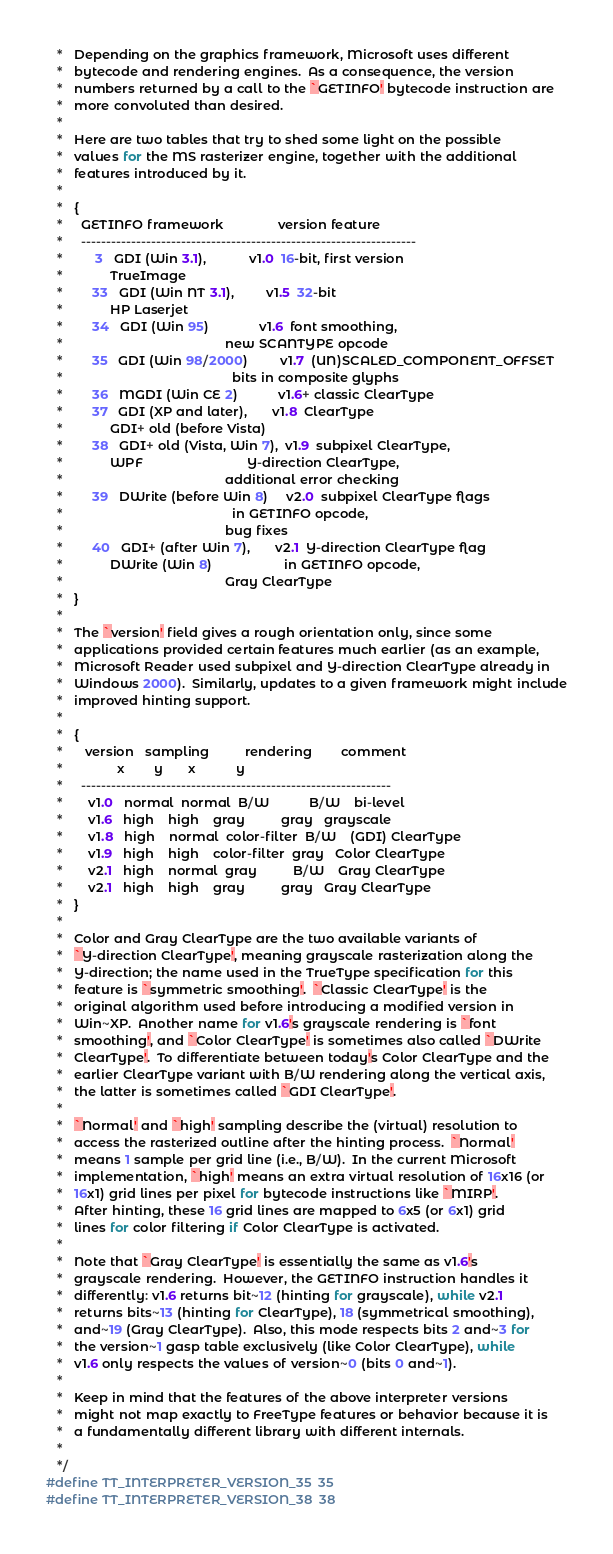<code> <loc_0><loc_0><loc_500><loc_500><_C_>   *   Depending on the graphics framework, Microsoft uses different
   *   bytecode and rendering engines.  As a consequence, the version
   *   numbers returned by a call to the `GETINFO' bytecode instruction are
   *   more convoluted than desired.
   *
   *   Here are two tables that try to shed some light on the possible
   *   values for the MS rasterizer engine, together with the additional
   *   features introduced by it.
   *
   *   {
   *     GETINFO framework               version feature
   *     -------------------------------------------------------------------
   *         3   GDI (Win 3.1),            v1.0  16-bit, first version
   *             TrueImage
   *        33   GDI (Win NT 3.1),         v1.5  32-bit
   *             HP Laserjet
   *        34   GDI (Win 95)              v1.6  font smoothing,
   *                                             new SCANTYPE opcode
   *        35   GDI (Win 98/2000)         v1.7  (UN)SCALED_COMPONENT_OFFSET
   *                                               bits in composite glyphs
   *        36   MGDI (Win CE 2)           v1.6+ classic ClearType
   *        37   GDI (XP and later),       v1.8  ClearType
   *             GDI+ old (before Vista)
   *        38   GDI+ old (Vista, Win 7),  v1.9  subpixel ClearType,
   *             WPF                             Y-direction ClearType,
   *                                             additional error checking
   *        39   DWrite (before Win 8)     v2.0  subpixel ClearType flags
   *                                               in GETINFO opcode,
   *                                             bug fixes
   *        40   GDI+ (after Win 7),       v2.1  Y-direction ClearType flag
   *             DWrite (Win 8)                    in GETINFO opcode,
   *                                             Gray ClearType
   *   }
   *
   *   The `version' field gives a rough orientation only, since some
   *   applications provided certain features much earlier (as an example,
   *   Microsoft Reader used subpixel and Y-direction ClearType already in
   *   Windows 2000).  Similarly, updates to a given framework might include
   *   improved hinting support.
   *
   *   {
   *      version   sampling          rendering        comment
   *               x        y       x           y
   *     --------------------------------------------------------------
   *       v1.0   normal  normal  B/W           B/W    bi-level
   *       v1.6   high    high    gray          gray   grayscale
   *       v1.8   high    normal  color-filter  B/W    (GDI) ClearType
   *       v1.9   high    high    color-filter  gray   Color ClearType
   *       v2.1   high    normal  gray          B/W    Gray ClearType
   *       v2.1   high    high    gray          gray   Gray ClearType
   *   }
   *
   *   Color and Gray ClearType are the two available variants of
   *   `Y-direction ClearType', meaning grayscale rasterization along the
   *   Y-direction; the name used in the TrueType specification for this
   *   feature is `symmetric smoothing'.  `Classic ClearType' is the
   *   original algorithm used before introducing a modified version in
   *   Win~XP.  Another name for v1.6's grayscale rendering is `font
   *   smoothing', and `Color ClearType' is sometimes also called `DWrite
   *   ClearType'.  To differentiate between today's Color ClearType and the
   *   earlier ClearType variant with B/W rendering along the vertical axis,
   *   the latter is sometimes called `GDI ClearType'.
   *
   *   `Normal' and `high' sampling describe the (virtual) resolution to
   *   access the rasterized outline after the hinting process.  `Normal'
   *   means 1 sample per grid line (i.e., B/W).  In the current Microsoft
   *   implementation, `high' means an extra virtual resolution of 16x16 (or
   *   16x1) grid lines per pixel for bytecode instructions like `MIRP'.
   *   After hinting, these 16 grid lines are mapped to 6x5 (or 6x1) grid
   *   lines for color filtering if Color ClearType is activated.
   *
   *   Note that `Gray ClearType' is essentially the same as v1.6's
   *   grayscale rendering.  However, the GETINFO instruction handles it
   *   differently: v1.6 returns bit~12 (hinting for grayscale), while v2.1
   *   returns bits~13 (hinting for ClearType), 18 (symmetrical smoothing),
   *   and~19 (Gray ClearType).  Also, this mode respects bits 2 and~3 for
   *   the version~1 gasp table exclusively (like Color ClearType), while
   *   v1.6 only respects the values of version~0 (bits 0 and~1).
   *
   *   Keep in mind that the features of the above interpreter versions
   *   might not map exactly to FreeType features or behavior because it is
   *   a fundamentally different library with different internals.
   *
   */
#define TT_INTERPRETER_VERSION_35  35
#define TT_INTERPRETER_VERSION_38  38</code> 